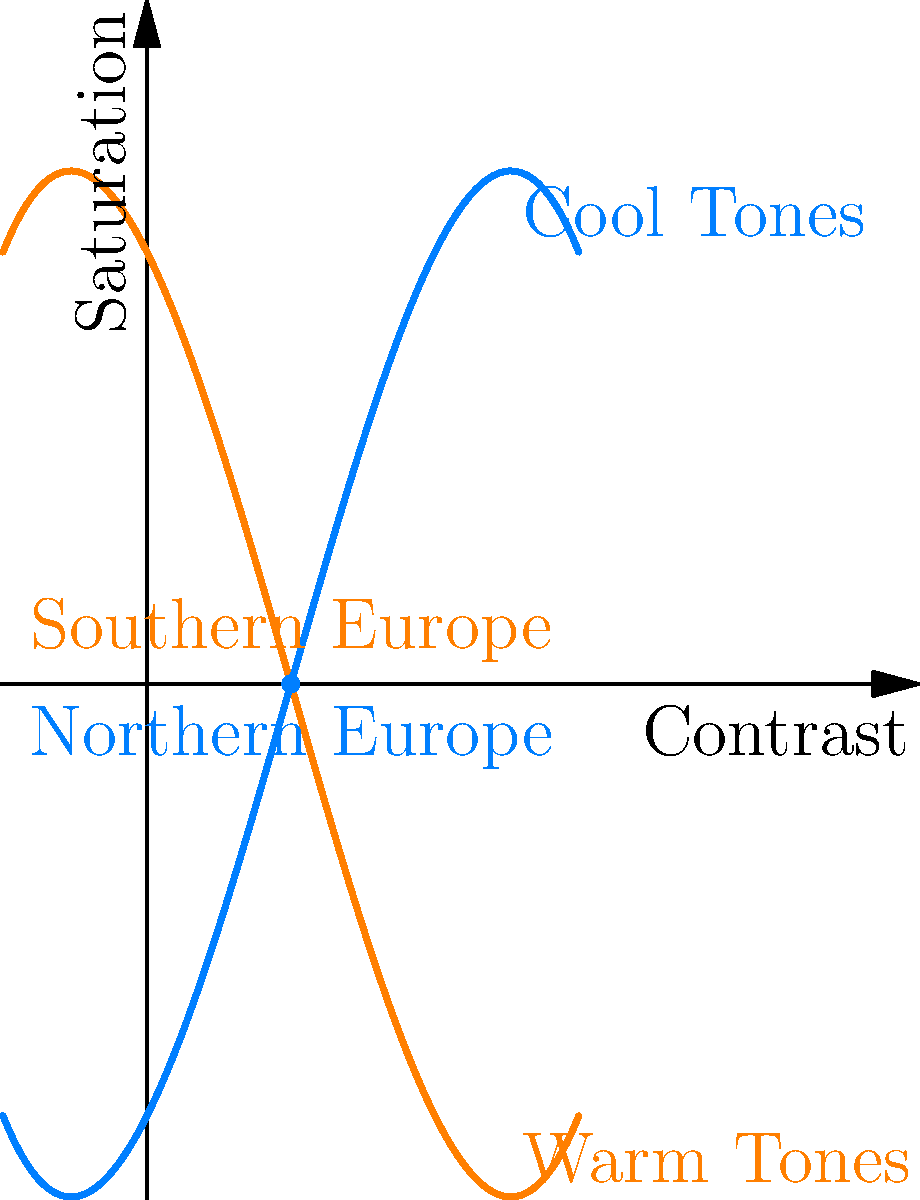In color grading for European settings, how would you adjust the contrast and saturation to convey the mood differences between Southern and Northern Europe, as shown in the graph? 1. Analyze the graph: The x-axis represents contrast, and the y-axis represents saturation.

2. Identify the curves: The upper (orange) curve represents warm tones, typically associated with Southern Europe, while the lower (blue) curve represents cool tones, associated with Northern Europe.

3. Compare the points for Southern and Northern Europe:
   - Southern Europe (orange dot): Higher saturation, moderate contrast
   - Northern Europe (blue dot): Lower saturation, moderate contrast

4. Interpret the mood implications:
   - Southern Europe: Warmer, more vibrant colors suggest a lively, energetic atmosphere
   - Northern Europe: Cooler, less saturated colors imply a more subdued, potentially melancholic mood

5. Color grading adjustments:
   - For Southern Europe: Increase saturation, maintain moderate contrast, emphasize warm tones (yellows, oranges)
   - For Northern Europe: Decrease saturation, maintain moderate contrast, emphasize cool tones (blues, greys)

6. Consider the overall curve shapes:
   - Southern Europe allows for more variation in saturation as contrast increases
   - Northern Europe shows a more consistent, lower saturation across contrast levels

7. Final color grading approach:
   - Southern Europe: Use higher saturation and warmer color temperature to convey a sun-drenched, vibrant atmosphere
   - Northern Europe: Use lower saturation and cooler color temperature to portray a more reserved, atmospheric mood
Answer: Increase saturation and warmth for Southern Europe; decrease saturation and cool tones for Northern Europe. 